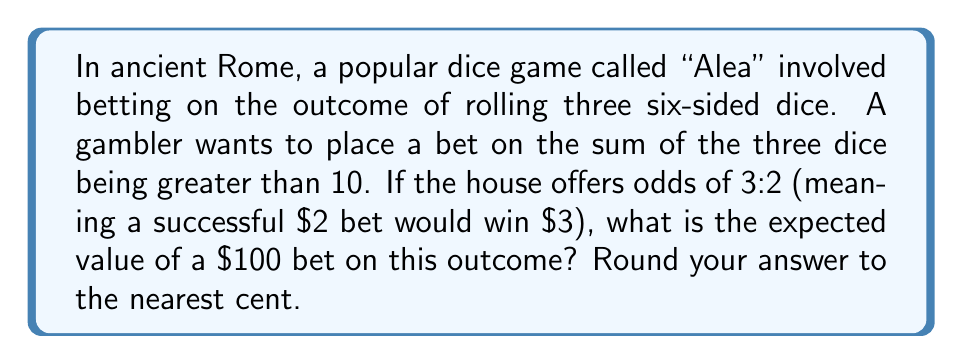Provide a solution to this math problem. To solve this problem, we need to follow these steps:

1. Calculate the probability of winning the bet:
   - Total possible outcomes: $6^3 = 216$ (6 possibilities for each of the 3 dice)
   - Favorable outcomes (sum > 10): 
     $$(5,5,1), (5,4,2), (5,3,3), (4,4,3), (4,3,4), (3,4,4), \ldots, (6,6,6)$$
   - Number of favorable outcomes: 216 - 27 = 189 (27 is the number of outcomes with sum ≤ 10)
   - Probability of winning: $P(\text{win}) = \frac{189}{216} = \frac{7}{8} = 0.875$

2. Calculate the probability of losing:
   $P(\text{lose}) = 1 - P(\text{win}) = 1 - \frac{7}{8} = \frac{1}{8} = 0.125$

3. Determine the payoff for winning and losing:
   - Win: $100 \times \frac{3}{2} = 150$ (profit of $50)
   - Lose: -$100

4. Calculate the expected value:
   $$E = P(\text{win}) \times \text{Win Amount} + P(\text{lose}) \times \text{Lose Amount}$$
   $$E = 0.875 \times 50 + 0.125 \times (-100)$$
   $$E = 43.75 - 12.5 = 31.25$$

Therefore, the expected value of a $100 bet is $31.25.
Answer: $31.25 